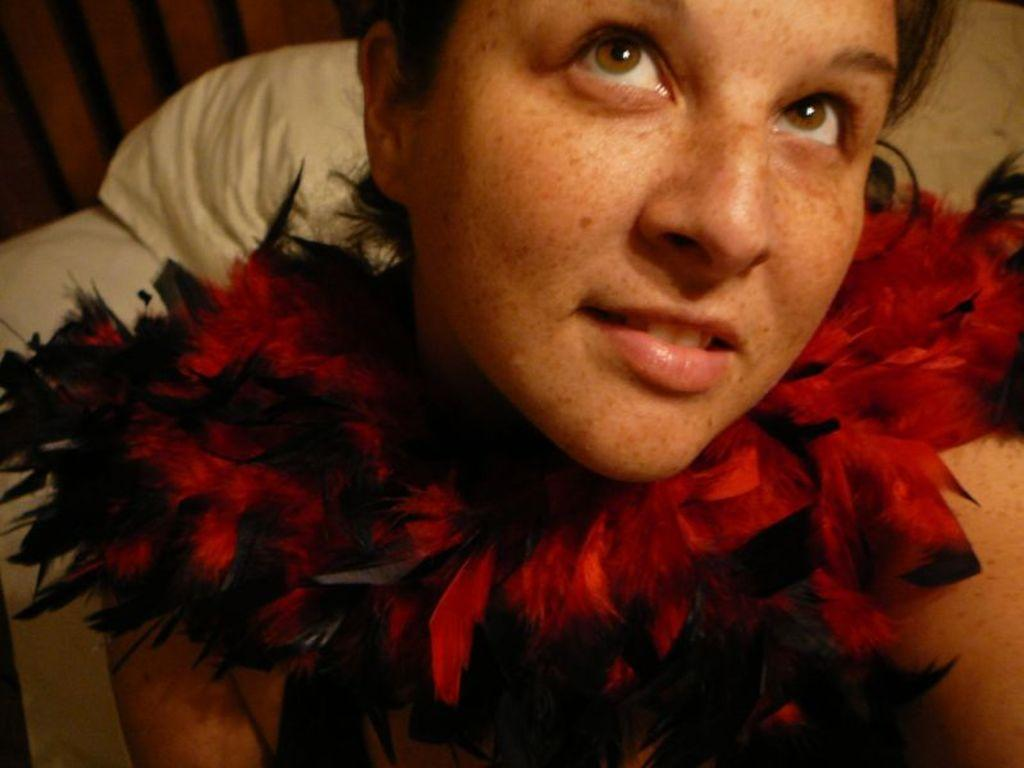Who is present in the image? There is a woman in the image. What is the woman wearing around her neck? The woman is wearing a red object around her neck. What else can be seen in the image besides the woman? There are other objects in the background of the image. What type of insect is crawling on the woman's shoulder in the image? There is no insect present on the woman's shoulder in the image. 